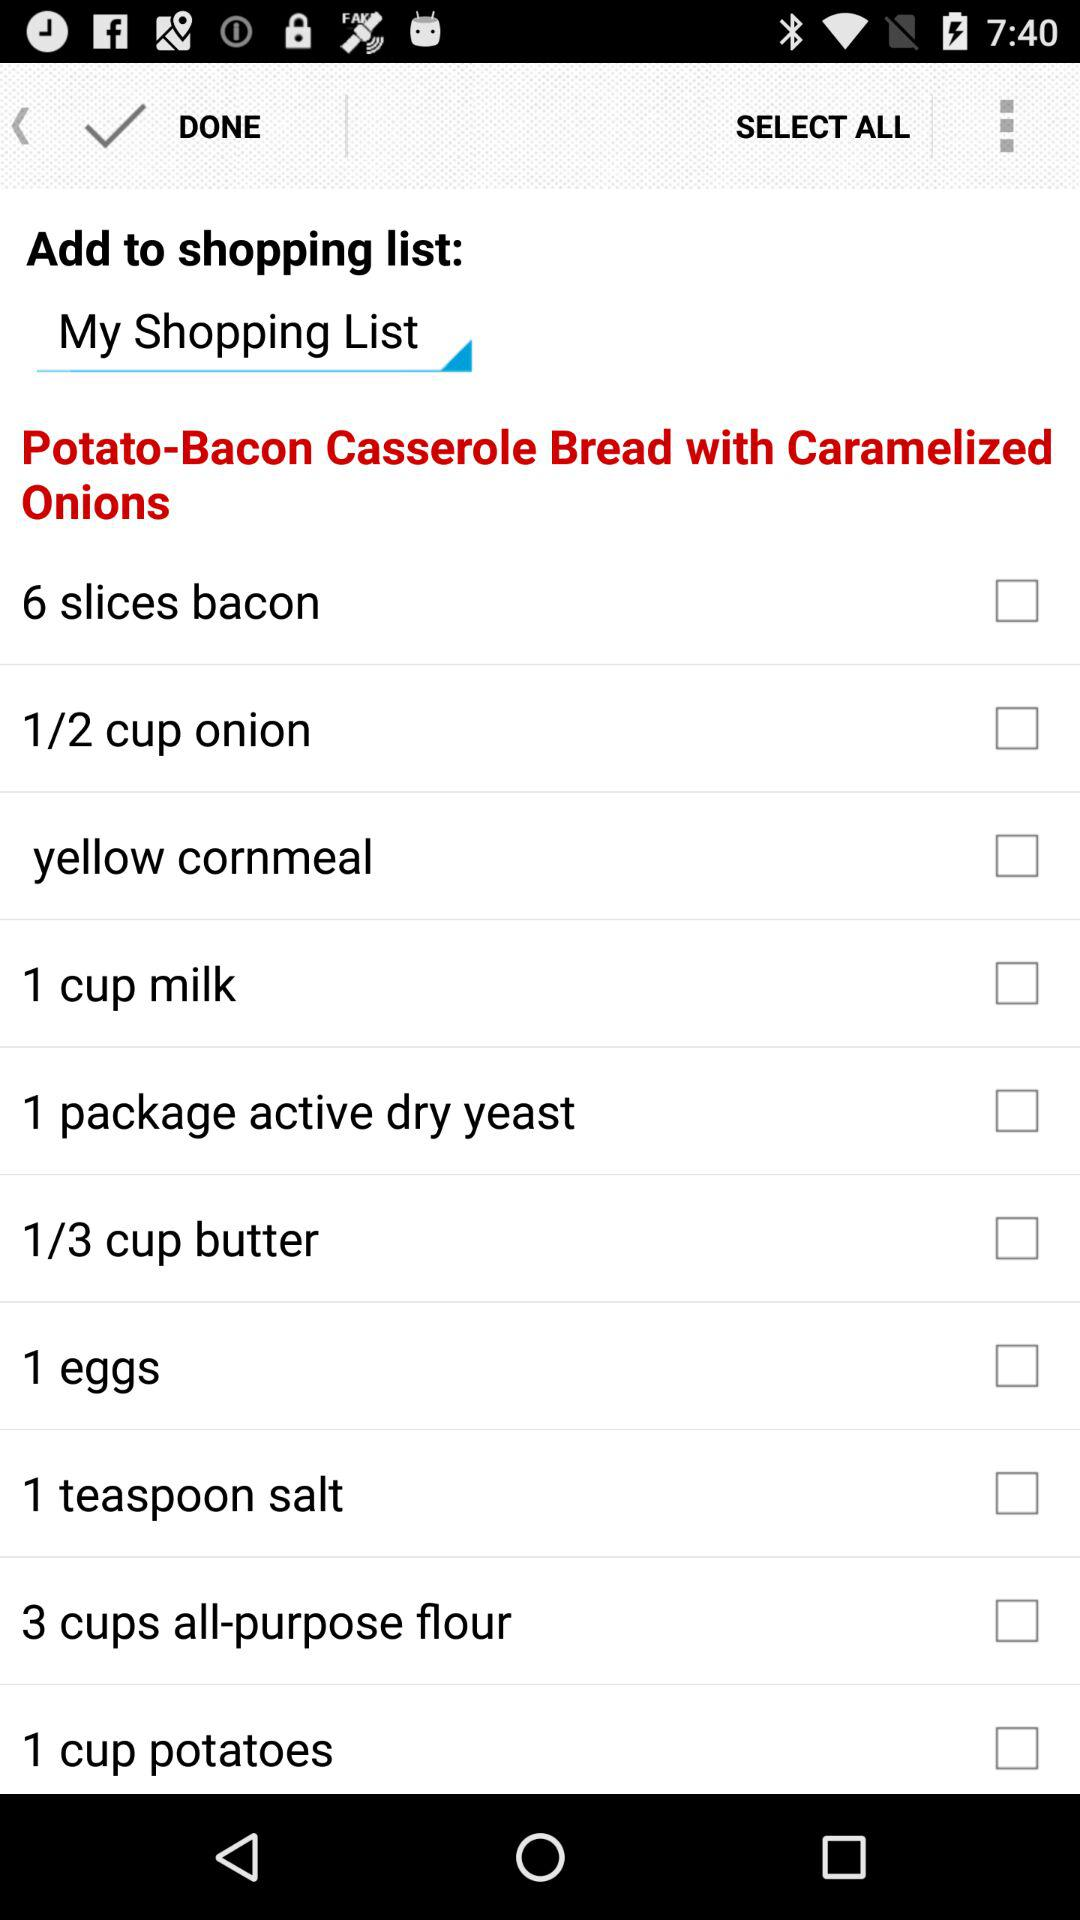What is the quantity of onion? The quantity of the onion is 1/2 cup. 